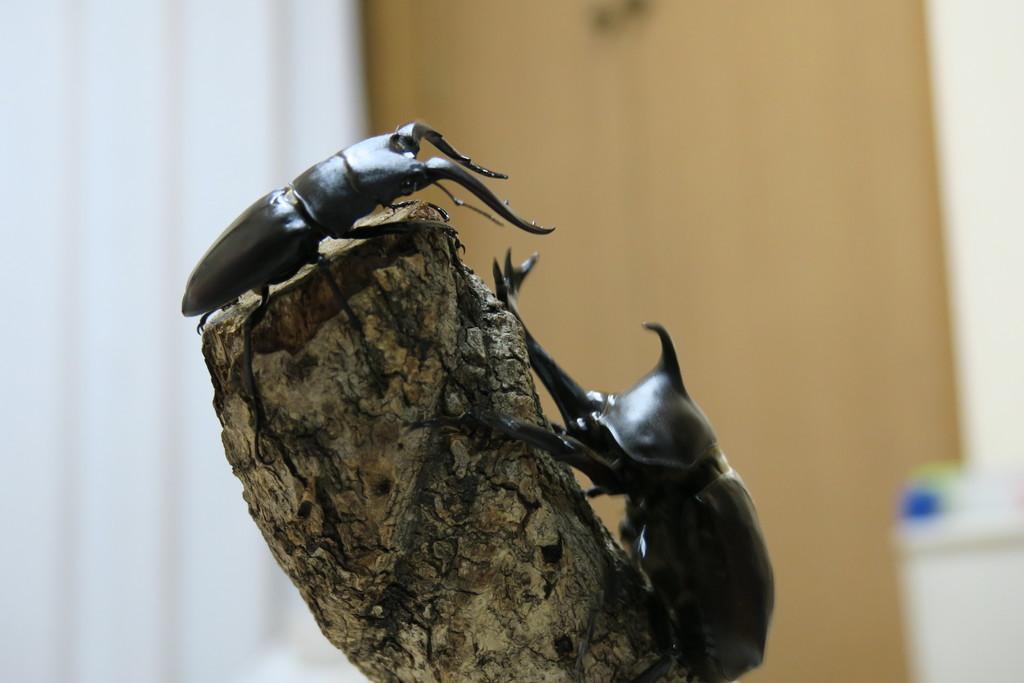Describe this image in one or two sentences. There are insects on a dry stick in the foreground area of the image and the background is blurry. 